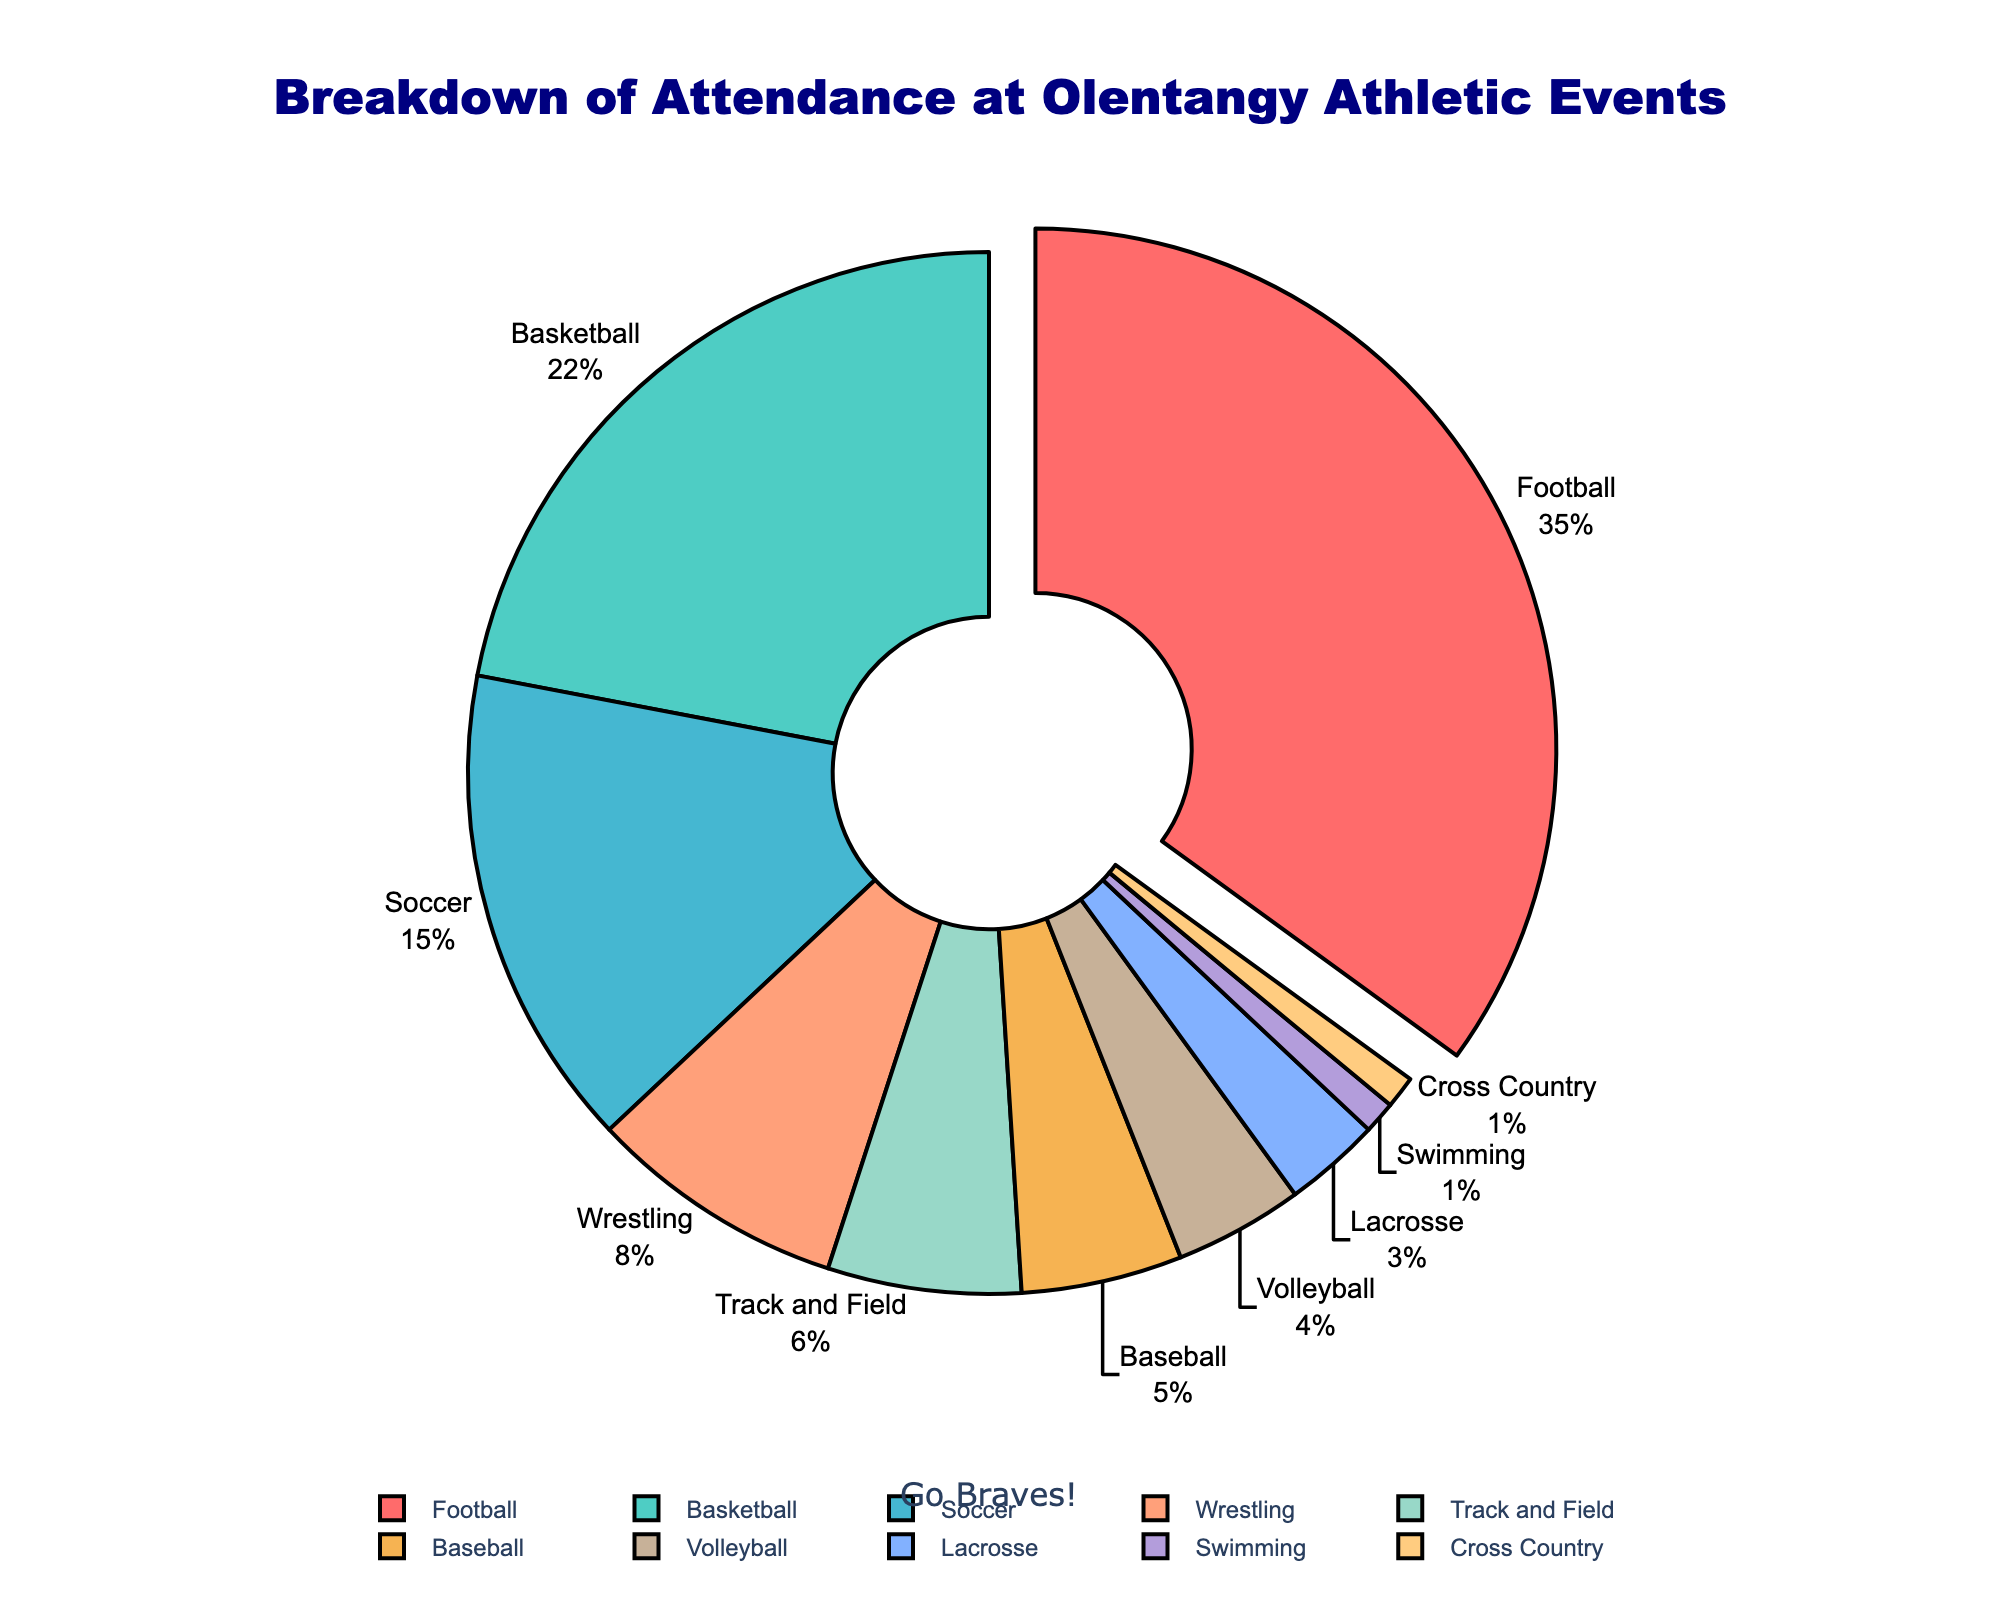Which sport has the highest attendance percentage? The sport with the highest attendance percentage can be identified by finding the sector of the pie chart that stands out the most. The chart highlights Football with 35% attendance, which is the highest.
Answer: Football What is the combined attendance percentage for Soccer, Baseball, and Lacrosse? Adding up the attendance percentages for Soccer (15%), Baseball (5%), and Lacrosse (3%) gives a combined total of 23%.
Answer: 23% Which sports account for less than 5% of attendance each? By observing the pie chart, the sports with less than 5% attendance are identified by their smaller pie slices. These sports are Volleyball (4%), Lacrosse (3%), Swimming (1%), and Cross Country (1%).
Answer: Volleyball, Lacrosse, Swimming, Cross Country How much greater is the attendance percentage for Football compared to Soccer? The difference between Football's attendance percentage (35%) and Soccer's attendance percentage (15%) is calculated as 35% - 15% = 20%.
Answer: 20% Which sport is represented by the red color in the pie chart? The legend of the pie chart helps identify the color corresponding to each sport. The red color represents Football.
Answer: Football What are the attendance percentages for Track and Field and Cross Country combined? Adding the attendance percentages for Track and Field (6%) and Cross Country (1%) results in a combined total of 7%.
Answer: 7% Which two sports together have an attendance percentage equal to Basketball’s attendance percentage? From the chart, Basketball has 22% attendance. By checking various combinations, Soccer (15%) and Wrestling (8%) sum up to 23%, which is the closest combination exceeding 22%. No two other sports sum exactly to 22%, hence Soccer and Wrestling is the closest.
Answer: Soccer, Wrestling What is the smallest slice in the pie chart, and what percentage does it represent? The smallest slice in the pie chart represents the category with the smallest attendance percentage. Swimming and Cross Country both have the smallest slice, representing 1% each.
Answer: Swimming, Cross Country Among soccer, basketball, and football, which has the second-highest attendance percentage? By comparing the percentages, Football has 35%, Basketball has 22%, and Soccer has 15%. The second-highest among these is Basketball with 22%.
Answer: Basketball What is the difference between the attendance percentages for Wrestling and Volleyball? The difference is calculated by subtracting Volleyball's percentage (4%) from Wrestling's percentage (8%), which results in 4%.
Answer: 4% 